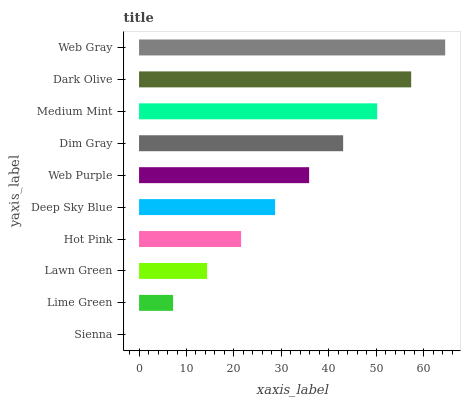Is Sienna the minimum?
Answer yes or no. Yes. Is Web Gray the maximum?
Answer yes or no. Yes. Is Lime Green the minimum?
Answer yes or no. No. Is Lime Green the maximum?
Answer yes or no. No. Is Lime Green greater than Sienna?
Answer yes or no. Yes. Is Sienna less than Lime Green?
Answer yes or no. Yes. Is Sienna greater than Lime Green?
Answer yes or no. No. Is Lime Green less than Sienna?
Answer yes or no. No. Is Web Purple the high median?
Answer yes or no. Yes. Is Deep Sky Blue the low median?
Answer yes or no. Yes. Is Dark Olive the high median?
Answer yes or no. No. Is Dark Olive the low median?
Answer yes or no. No. 